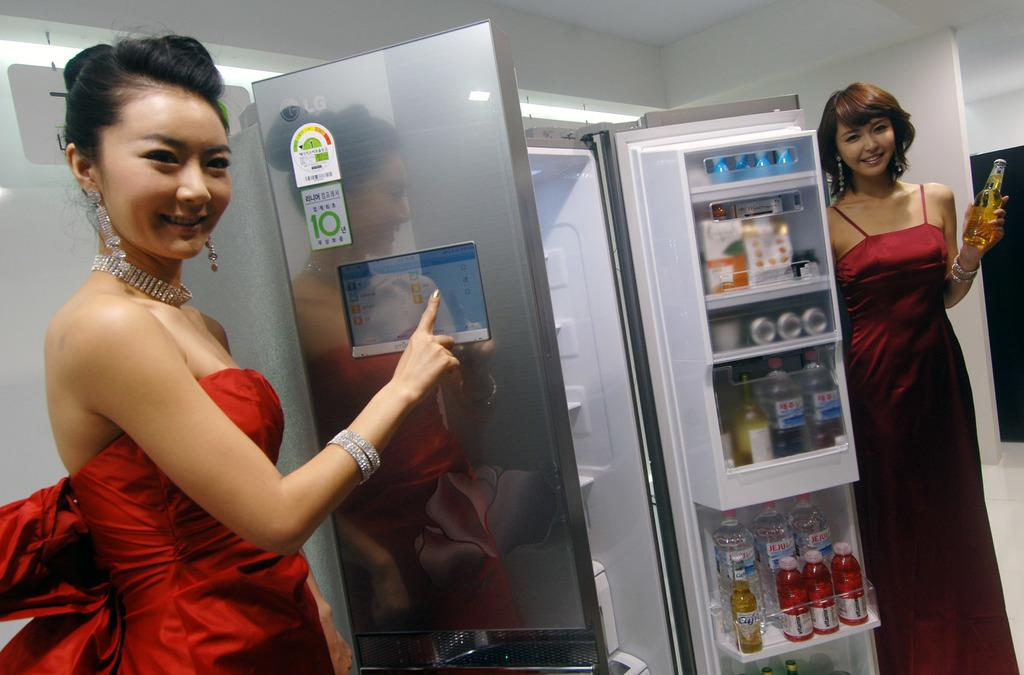Provide a one-sentence caption for the provided image. A girl stands near an open fridge that has a white label with the number 10 on the door. 